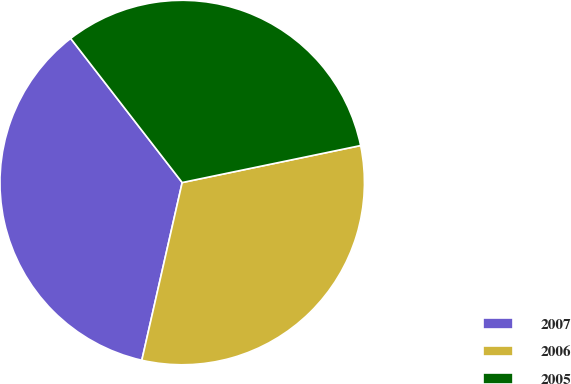Convert chart. <chart><loc_0><loc_0><loc_500><loc_500><pie_chart><fcel>2007<fcel>2006<fcel>2005<nl><fcel>35.96%<fcel>31.81%<fcel>32.23%<nl></chart> 